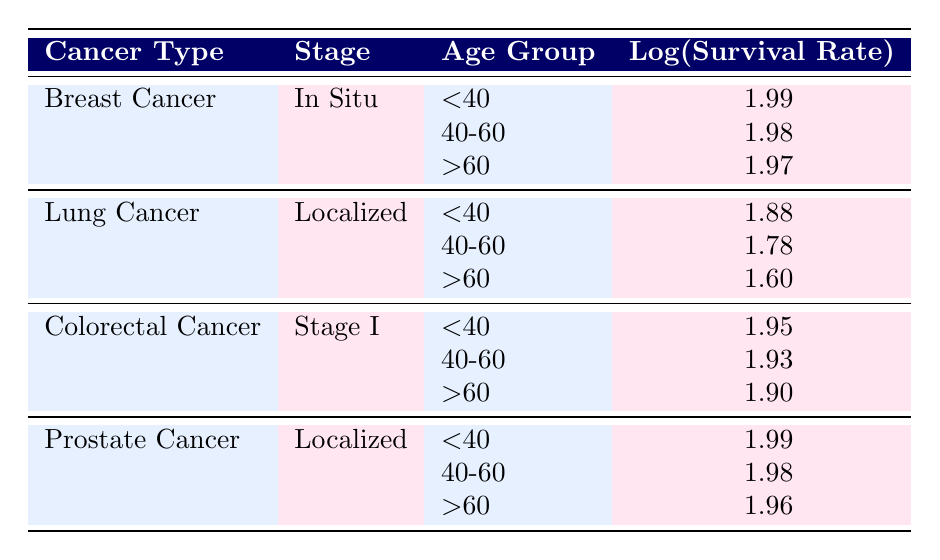What is the 5-year survival rate for Breast Cancer in patients aged 40-60? The table shows that for Breast Cancer, the 5-year survival rate for the age group 40-60 is listed as 95.
Answer: 95 What is the 5-year survival rate for Lung Cancer in patients aged over 60? The table indicates that for Lung Cancer in the age group over 60, the 5-year survival rate is 40.
Answer: 40 Which cancer type has the highest survival rate for patients under 40? Upon examining the data, Breast Cancer and Prostate Cancer both have a survival rate of 98 for patients under 40, which is higher than the rates for the other cancer types listed.
Answer: Breast Cancer and Prostate Cancer Is the 5-year survival rate for Colorectal Cancer lower than that for Lung Cancer in patients aged 40-60? For Colorectal Cancer in the 40-60 age group, the survival rate is 85, while for Lung Cancer, it's 60. Since 85 is greater than 60, the answer is no.
Answer: No What is the average 5-year survival rate for Prostate Cancer across all age groups listed? The survival rates for Prostate Cancer are 98, 95, and 91 for the age groups below 40, between 40-60, and over 60, respectively. Adding these gives 98+95+91=284, and dividing by 3 gives an average of 284/3 = approximately 94.67.
Answer: 94.67 For which cancer type does the survival rate decrease the most as the age group increases? By evaluating the survival rates across age groups for each cancer type, we see that Lung Cancer decreases from 75 to 40, a difference of 35 points, while for others, the decrease is less: Breast Cancer (4), Colorectal Cancer (10), and Prostate Cancer (7). Thus, Lung Cancer has the highest decrease.
Answer: Lung Cancer Is the 5-year survival rate for Colorectal Cancer in patients below 40 higher than that for Breast Cancer in patients over 60? The survival rate for Colorectal Cancer in patients below 40 is 90, while for Breast Cancer in patients over 60, it's 93. Since 90 is less than 93, the answer is no.
Answer: No What is the difference in the 5-year survival rates for Lung Cancer between patients aged under 40 and those aged over 60? The survival rate for Lung Cancer for patients under 40 is 75, and for those over 60, it is 40. The difference is calculated by subtracting: 75 - 40 = 35.
Answer: 35 Which cancer type has a survival rate of 93 in any of the age groups? Examining the table, only Breast Cancer shows a survival rate of 93 for the age group over 60. No other cancer type has a survival rate of 93.
Answer: Breast Cancer 